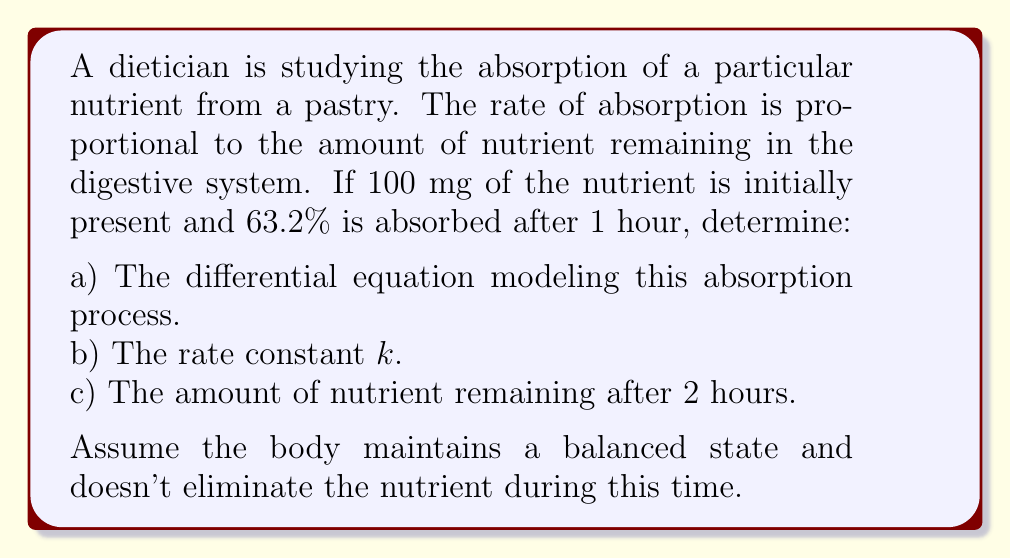Give your solution to this math problem. Let's approach this step-by-step:

a) The differential equation:
   Let $N(t)$ be the amount of nutrient remaining at time $t$ (in hours).
   The rate of change is proportional to the amount remaining:
   
   $$\frac{dN}{dt} = -kN$$
   
   where $k$ is the rate constant.

b) Finding the rate constant $k$:
   The solution to this differential equation is:
   
   $$N(t) = N_0e^{-kt}$$
   
   where $N_0$ is the initial amount.

   We know that $N_0 = 100$ mg and after 1 hour, 63.2% is absorbed, meaning 36.8% remains.
   
   $$N(1) = 36.8 = 100e^{-k(1)}$$
   
   $$0.368 = e^{-k}$$
   
   Taking natural log of both sides:
   
   $$\ln(0.368) = -k$$
   
   $$k = -\ln(0.368) \approx 1$$

c) Amount remaining after 2 hours:
   Using the solution $N(t) = N_0e^{-kt}$ with $k = 1$:
   
   $$N(2) = 100e^{-1(2)} = 100e^{-2}$$

   $$N(2) = 100 * (e^{-1})^2 \approx 100 * 0.368^2 \approx 13.5$$

This model demonstrates how nutrients from a pastry might be absorbed, emphasizing the importance of understanding nutrient uptake in balanced eating.
Answer: a) $\frac{dN}{dt} = -kN$
b) $k \approx 1$ hour$^{-1}$
c) Approximately 13.5 mg of nutrient remains after 2 hours. 